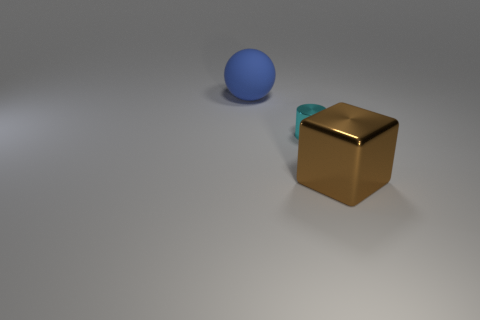Add 1 cyan cylinders. How many objects exist? 4 Subtract all cylinders. How many objects are left? 2 Subtract all tiny cyan cylinders. Subtract all blue things. How many objects are left? 1 Add 3 small objects. How many small objects are left? 4 Add 1 big blue matte spheres. How many big blue matte spheres exist? 2 Subtract 0 gray blocks. How many objects are left? 3 